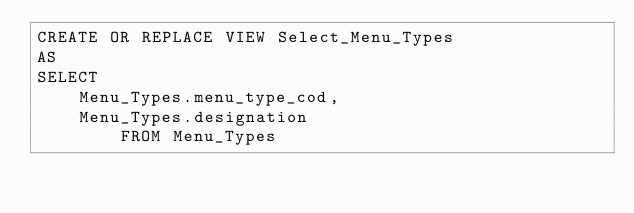<code> <loc_0><loc_0><loc_500><loc_500><_SQL_>CREATE OR REPLACE VIEW Select_Menu_Types
AS
SELECT 
    Menu_Types.menu_type_cod,
    Menu_Types.designation 
        FROM Menu_Types</code> 